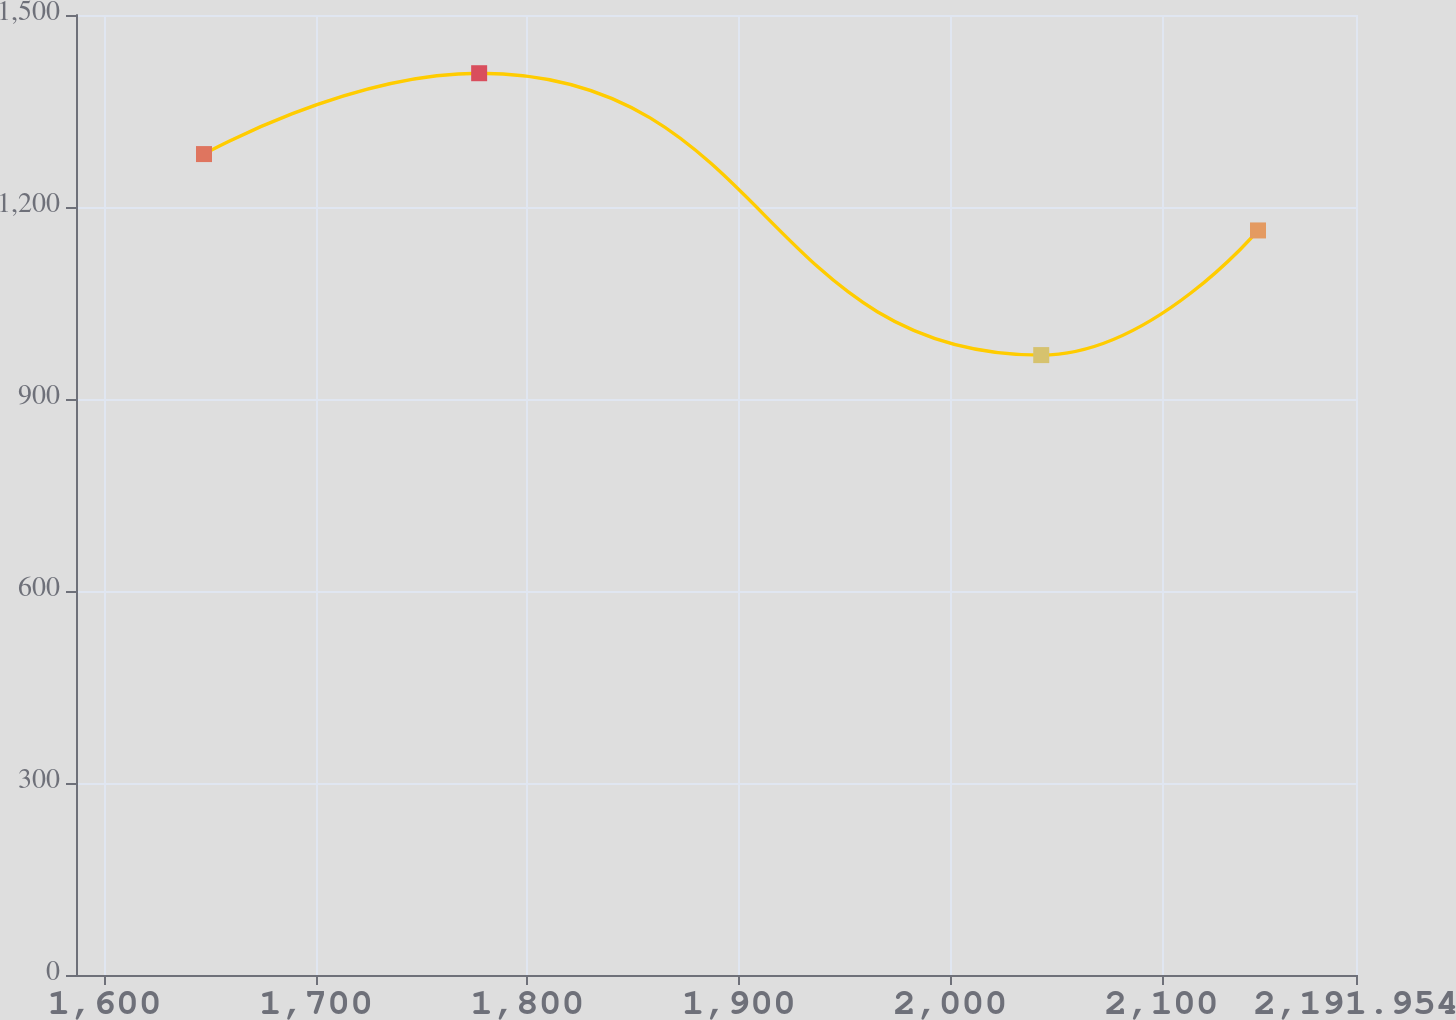<chart> <loc_0><loc_0><loc_500><loc_500><line_chart><ecel><fcel>Unnamed: 1<nl><fcel>1647.04<fcel>1282.68<nl><fcel>1777.19<fcel>1409.02<nl><fcel>2043.06<fcel>968.59<nl><fcel>2145.59<fcel>1163.35<nl><fcel>2252.5<fcel>629.47<nl></chart> 